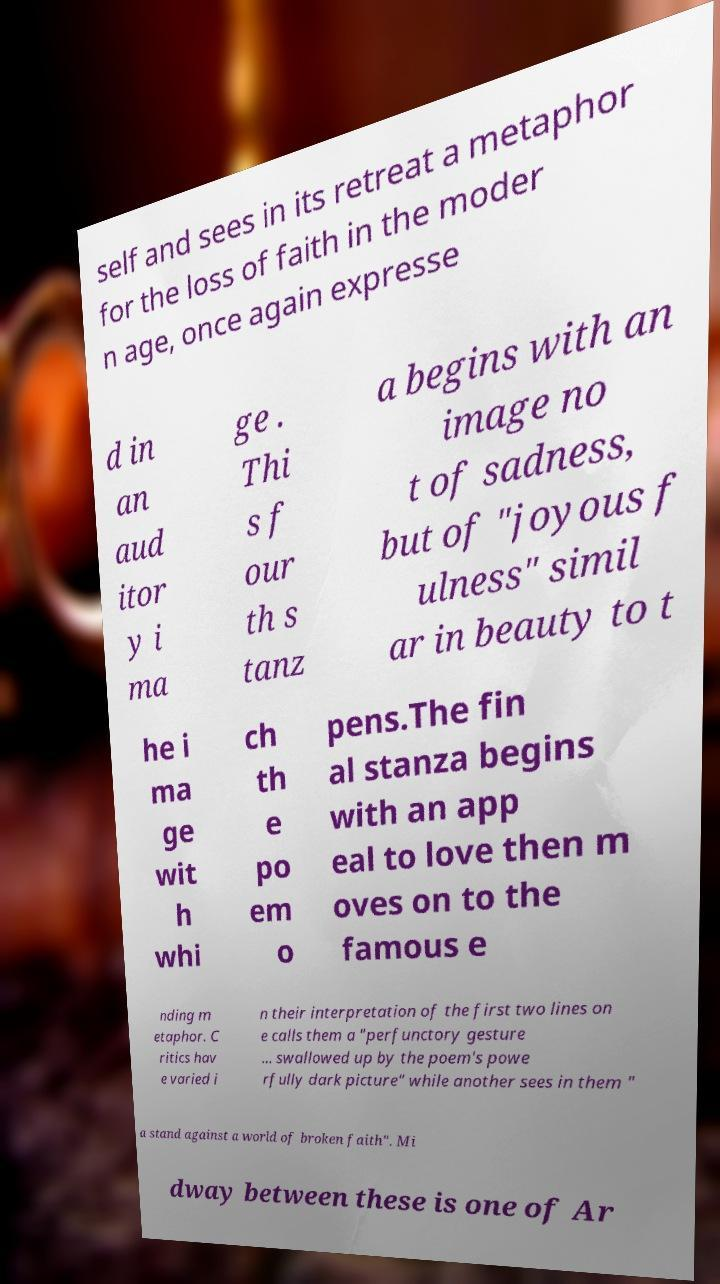There's text embedded in this image that I need extracted. Can you transcribe it verbatim? self and sees in its retreat a metaphor for the loss of faith in the moder n age, once again expresse d in an aud itor y i ma ge . Thi s f our th s tanz a begins with an image no t of sadness, but of "joyous f ulness" simil ar in beauty to t he i ma ge wit h whi ch th e po em o pens.The fin al stanza begins with an app eal to love then m oves on to the famous e nding m etaphor. C ritics hav e varied i n their interpretation of the first two lines on e calls them a "perfunctory gesture ... swallowed up by the poem's powe rfully dark picture" while another sees in them " a stand against a world of broken faith". Mi dway between these is one of Ar 